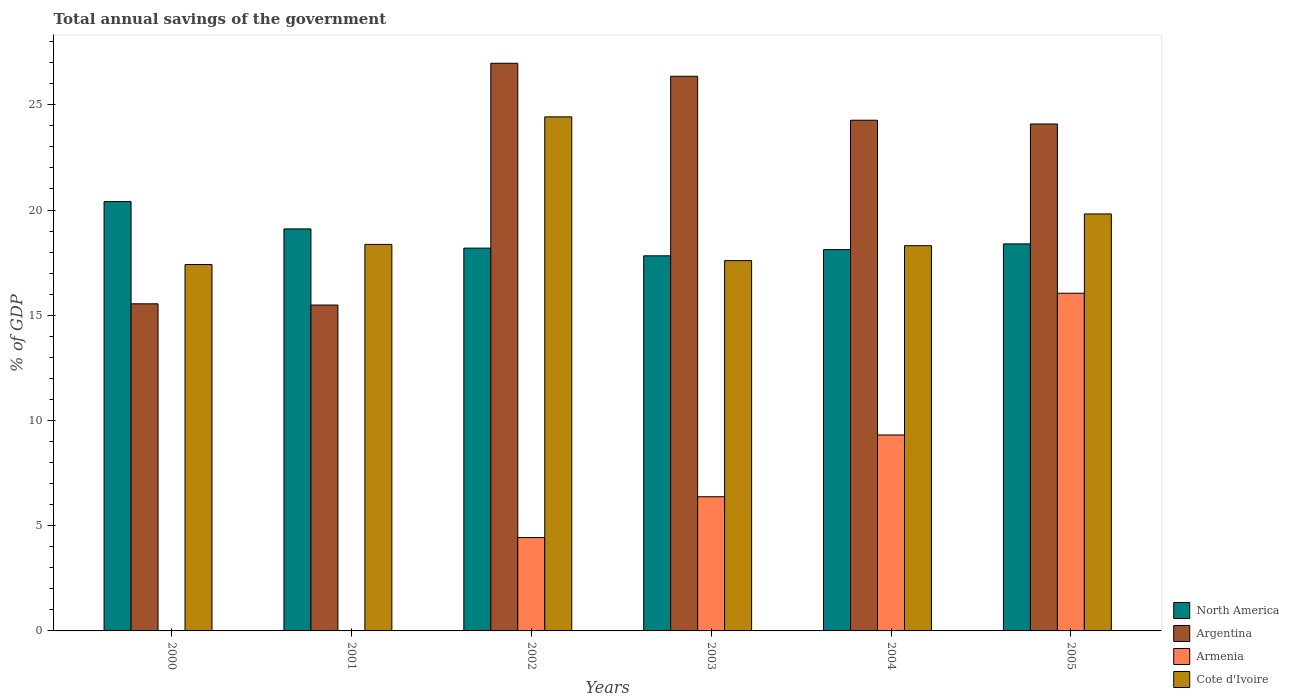How many different coloured bars are there?
Offer a very short reply. 4. How many groups of bars are there?
Provide a short and direct response. 6. Are the number of bars per tick equal to the number of legend labels?
Keep it short and to the point. No. What is the total annual savings of the government in North America in 2005?
Your answer should be compact. 18.39. Across all years, what is the maximum total annual savings of the government in North America?
Ensure brevity in your answer.  20.4. Across all years, what is the minimum total annual savings of the government in North America?
Make the answer very short. 17.82. What is the total total annual savings of the government in Cote d'Ivoire in the graph?
Give a very brief answer. 115.91. What is the difference between the total annual savings of the government in Argentina in 2001 and that in 2004?
Your answer should be compact. -8.78. What is the difference between the total annual savings of the government in Cote d'Ivoire in 2005 and the total annual savings of the government in Armenia in 2004?
Give a very brief answer. 10.5. What is the average total annual savings of the government in Armenia per year?
Provide a short and direct response. 6.03. In the year 2004, what is the difference between the total annual savings of the government in Cote d'Ivoire and total annual savings of the government in Argentina?
Keep it short and to the point. -5.96. What is the ratio of the total annual savings of the government in North America in 2000 to that in 2004?
Your answer should be compact. 1.13. Is the total annual savings of the government in Cote d'Ivoire in 2001 less than that in 2005?
Make the answer very short. Yes. Is the difference between the total annual savings of the government in Cote d'Ivoire in 2002 and 2004 greater than the difference between the total annual savings of the government in Argentina in 2002 and 2004?
Offer a very short reply. Yes. What is the difference between the highest and the second highest total annual savings of the government in Cote d'Ivoire?
Your response must be concise. 4.61. What is the difference between the highest and the lowest total annual savings of the government in Armenia?
Ensure brevity in your answer.  16.05. In how many years, is the total annual savings of the government in Argentina greater than the average total annual savings of the government in Argentina taken over all years?
Your response must be concise. 4. Is the sum of the total annual savings of the government in Armenia in 2002 and 2004 greater than the maximum total annual savings of the government in Argentina across all years?
Offer a very short reply. No. How many bars are there?
Keep it short and to the point. 22. Does the graph contain grids?
Keep it short and to the point. No. Where does the legend appear in the graph?
Ensure brevity in your answer.  Bottom right. What is the title of the graph?
Provide a short and direct response. Total annual savings of the government. Does "Nicaragua" appear as one of the legend labels in the graph?
Offer a terse response. No. What is the label or title of the X-axis?
Provide a succinct answer. Years. What is the label or title of the Y-axis?
Keep it short and to the point. % of GDP. What is the % of GDP in North America in 2000?
Provide a succinct answer. 20.4. What is the % of GDP of Argentina in 2000?
Ensure brevity in your answer.  15.54. What is the % of GDP of Armenia in 2000?
Offer a terse response. 0. What is the % of GDP in Cote d'Ivoire in 2000?
Offer a very short reply. 17.41. What is the % of GDP of North America in 2001?
Offer a very short reply. 19.1. What is the % of GDP of Argentina in 2001?
Provide a short and direct response. 15.49. What is the % of GDP of Armenia in 2001?
Provide a short and direct response. 0. What is the % of GDP in Cote d'Ivoire in 2001?
Your answer should be very brief. 18.37. What is the % of GDP in North America in 2002?
Give a very brief answer. 18.19. What is the % of GDP of Argentina in 2002?
Your answer should be very brief. 26.97. What is the % of GDP in Armenia in 2002?
Provide a short and direct response. 4.44. What is the % of GDP in Cote d'Ivoire in 2002?
Keep it short and to the point. 24.43. What is the % of GDP in North America in 2003?
Give a very brief answer. 17.82. What is the % of GDP in Argentina in 2003?
Provide a short and direct response. 26.35. What is the % of GDP in Armenia in 2003?
Keep it short and to the point. 6.38. What is the % of GDP of Cote d'Ivoire in 2003?
Offer a terse response. 17.59. What is the % of GDP in North America in 2004?
Ensure brevity in your answer.  18.12. What is the % of GDP in Argentina in 2004?
Your response must be concise. 24.27. What is the % of GDP in Armenia in 2004?
Offer a terse response. 9.31. What is the % of GDP in Cote d'Ivoire in 2004?
Offer a terse response. 18.3. What is the % of GDP in North America in 2005?
Provide a succinct answer. 18.39. What is the % of GDP in Argentina in 2005?
Your answer should be very brief. 24.09. What is the % of GDP of Armenia in 2005?
Your response must be concise. 16.05. What is the % of GDP in Cote d'Ivoire in 2005?
Ensure brevity in your answer.  19.81. Across all years, what is the maximum % of GDP in North America?
Make the answer very short. 20.4. Across all years, what is the maximum % of GDP in Argentina?
Provide a succinct answer. 26.97. Across all years, what is the maximum % of GDP in Armenia?
Your answer should be very brief. 16.05. Across all years, what is the maximum % of GDP of Cote d'Ivoire?
Make the answer very short. 24.43. Across all years, what is the minimum % of GDP of North America?
Your response must be concise. 17.82. Across all years, what is the minimum % of GDP of Argentina?
Make the answer very short. 15.49. Across all years, what is the minimum % of GDP of Cote d'Ivoire?
Offer a very short reply. 17.41. What is the total % of GDP in North America in the graph?
Offer a terse response. 112.02. What is the total % of GDP in Argentina in the graph?
Provide a succinct answer. 132.71. What is the total % of GDP in Armenia in the graph?
Make the answer very short. 36.17. What is the total % of GDP in Cote d'Ivoire in the graph?
Your answer should be very brief. 115.91. What is the difference between the % of GDP of North America in 2000 and that in 2001?
Make the answer very short. 1.3. What is the difference between the % of GDP in Argentina in 2000 and that in 2001?
Your response must be concise. 0.06. What is the difference between the % of GDP of Cote d'Ivoire in 2000 and that in 2001?
Provide a succinct answer. -0.96. What is the difference between the % of GDP of North America in 2000 and that in 2002?
Offer a very short reply. 2.21. What is the difference between the % of GDP of Argentina in 2000 and that in 2002?
Offer a very short reply. -11.43. What is the difference between the % of GDP in Cote d'Ivoire in 2000 and that in 2002?
Your answer should be very brief. -7.02. What is the difference between the % of GDP of North America in 2000 and that in 2003?
Your answer should be compact. 2.58. What is the difference between the % of GDP in Argentina in 2000 and that in 2003?
Provide a succinct answer. -10.81. What is the difference between the % of GDP of Cote d'Ivoire in 2000 and that in 2003?
Offer a very short reply. -0.19. What is the difference between the % of GDP of North America in 2000 and that in 2004?
Offer a terse response. 2.28. What is the difference between the % of GDP of Argentina in 2000 and that in 2004?
Your response must be concise. -8.72. What is the difference between the % of GDP of Cote d'Ivoire in 2000 and that in 2004?
Give a very brief answer. -0.9. What is the difference between the % of GDP in North America in 2000 and that in 2005?
Offer a terse response. 2.01. What is the difference between the % of GDP in Argentina in 2000 and that in 2005?
Make the answer very short. -8.55. What is the difference between the % of GDP in Cote d'Ivoire in 2000 and that in 2005?
Provide a short and direct response. -2.4. What is the difference between the % of GDP of North America in 2001 and that in 2002?
Offer a very short reply. 0.91. What is the difference between the % of GDP in Argentina in 2001 and that in 2002?
Offer a terse response. -11.49. What is the difference between the % of GDP in Cote d'Ivoire in 2001 and that in 2002?
Provide a short and direct response. -6.06. What is the difference between the % of GDP in North America in 2001 and that in 2003?
Offer a terse response. 1.28. What is the difference between the % of GDP in Argentina in 2001 and that in 2003?
Give a very brief answer. -10.87. What is the difference between the % of GDP of Cote d'Ivoire in 2001 and that in 2003?
Your answer should be very brief. 0.77. What is the difference between the % of GDP in North America in 2001 and that in 2004?
Ensure brevity in your answer.  0.98. What is the difference between the % of GDP of Argentina in 2001 and that in 2004?
Your response must be concise. -8.78. What is the difference between the % of GDP of Cote d'Ivoire in 2001 and that in 2004?
Your answer should be compact. 0.06. What is the difference between the % of GDP in North America in 2001 and that in 2005?
Offer a very short reply. 0.71. What is the difference between the % of GDP of Argentina in 2001 and that in 2005?
Offer a terse response. -8.6. What is the difference between the % of GDP in Cote d'Ivoire in 2001 and that in 2005?
Give a very brief answer. -1.45. What is the difference between the % of GDP in North America in 2002 and that in 2003?
Provide a short and direct response. 0.36. What is the difference between the % of GDP in Argentina in 2002 and that in 2003?
Your answer should be very brief. 0.62. What is the difference between the % of GDP of Armenia in 2002 and that in 2003?
Your answer should be very brief. -1.94. What is the difference between the % of GDP in Cote d'Ivoire in 2002 and that in 2003?
Your response must be concise. 6.83. What is the difference between the % of GDP of North America in 2002 and that in 2004?
Give a very brief answer. 0.07. What is the difference between the % of GDP in Argentina in 2002 and that in 2004?
Offer a very short reply. 2.71. What is the difference between the % of GDP in Armenia in 2002 and that in 2004?
Offer a very short reply. -4.87. What is the difference between the % of GDP of Cote d'Ivoire in 2002 and that in 2004?
Provide a short and direct response. 6.12. What is the difference between the % of GDP in North America in 2002 and that in 2005?
Provide a short and direct response. -0.2. What is the difference between the % of GDP of Argentina in 2002 and that in 2005?
Offer a terse response. 2.88. What is the difference between the % of GDP of Armenia in 2002 and that in 2005?
Provide a short and direct response. -11.61. What is the difference between the % of GDP of Cote d'Ivoire in 2002 and that in 2005?
Your answer should be compact. 4.61. What is the difference between the % of GDP in North America in 2003 and that in 2004?
Offer a very short reply. -0.3. What is the difference between the % of GDP in Argentina in 2003 and that in 2004?
Provide a succinct answer. 2.09. What is the difference between the % of GDP of Armenia in 2003 and that in 2004?
Your answer should be very brief. -2.94. What is the difference between the % of GDP of Cote d'Ivoire in 2003 and that in 2004?
Ensure brevity in your answer.  -0.71. What is the difference between the % of GDP in North America in 2003 and that in 2005?
Offer a very short reply. -0.57. What is the difference between the % of GDP of Argentina in 2003 and that in 2005?
Your answer should be compact. 2.27. What is the difference between the % of GDP of Armenia in 2003 and that in 2005?
Keep it short and to the point. -9.67. What is the difference between the % of GDP of Cote d'Ivoire in 2003 and that in 2005?
Your response must be concise. -2.22. What is the difference between the % of GDP in North America in 2004 and that in 2005?
Keep it short and to the point. -0.27. What is the difference between the % of GDP in Argentina in 2004 and that in 2005?
Your response must be concise. 0.18. What is the difference between the % of GDP in Armenia in 2004 and that in 2005?
Your response must be concise. -6.74. What is the difference between the % of GDP of Cote d'Ivoire in 2004 and that in 2005?
Ensure brevity in your answer.  -1.51. What is the difference between the % of GDP in North America in 2000 and the % of GDP in Argentina in 2001?
Your response must be concise. 4.92. What is the difference between the % of GDP of North America in 2000 and the % of GDP of Cote d'Ivoire in 2001?
Ensure brevity in your answer.  2.04. What is the difference between the % of GDP of Argentina in 2000 and the % of GDP of Cote d'Ivoire in 2001?
Offer a very short reply. -2.82. What is the difference between the % of GDP in North America in 2000 and the % of GDP in Argentina in 2002?
Your answer should be compact. -6.57. What is the difference between the % of GDP of North America in 2000 and the % of GDP of Armenia in 2002?
Your answer should be compact. 15.96. What is the difference between the % of GDP of North America in 2000 and the % of GDP of Cote d'Ivoire in 2002?
Provide a succinct answer. -4.02. What is the difference between the % of GDP in Argentina in 2000 and the % of GDP in Armenia in 2002?
Provide a short and direct response. 11.11. What is the difference between the % of GDP of Argentina in 2000 and the % of GDP of Cote d'Ivoire in 2002?
Your answer should be very brief. -8.88. What is the difference between the % of GDP of North America in 2000 and the % of GDP of Argentina in 2003?
Ensure brevity in your answer.  -5.95. What is the difference between the % of GDP of North America in 2000 and the % of GDP of Armenia in 2003?
Offer a very short reply. 14.03. What is the difference between the % of GDP of North America in 2000 and the % of GDP of Cote d'Ivoire in 2003?
Make the answer very short. 2.81. What is the difference between the % of GDP of Argentina in 2000 and the % of GDP of Armenia in 2003?
Your response must be concise. 9.17. What is the difference between the % of GDP of Argentina in 2000 and the % of GDP of Cote d'Ivoire in 2003?
Ensure brevity in your answer.  -2.05. What is the difference between the % of GDP in North America in 2000 and the % of GDP in Argentina in 2004?
Your response must be concise. -3.87. What is the difference between the % of GDP in North America in 2000 and the % of GDP in Armenia in 2004?
Ensure brevity in your answer.  11.09. What is the difference between the % of GDP in North America in 2000 and the % of GDP in Cote d'Ivoire in 2004?
Your response must be concise. 2.1. What is the difference between the % of GDP in Argentina in 2000 and the % of GDP in Armenia in 2004?
Your answer should be compact. 6.23. What is the difference between the % of GDP in Argentina in 2000 and the % of GDP in Cote d'Ivoire in 2004?
Offer a terse response. -2.76. What is the difference between the % of GDP of North America in 2000 and the % of GDP of Argentina in 2005?
Keep it short and to the point. -3.69. What is the difference between the % of GDP in North America in 2000 and the % of GDP in Armenia in 2005?
Offer a terse response. 4.36. What is the difference between the % of GDP of North America in 2000 and the % of GDP of Cote d'Ivoire in 2005?
Offer a terse response. 0.59. What is the difference between the % of GDP in Argentina in 2000 and the % of GDP in Armenia in 2005?
Your answer should be very brief. -0.5. What is the difference between the % of GDP of Argentina in 2000 and the % of GDP of Cote d'Ivoire in 2005?
Keep it short and to the point. -4.27. What is the difference between the % of GDP in North America in 2001 and the % of GDP in Argentina in 2002?
Your answer should be compact. -7.87. What is the difference between the % of GDP in North America in 2001 and the % of GDP in Armenia in 2002?
Your answer should be compact. 14.66. What is the difference between the % of GDP of North America in 2001 and the % of GDP of Cote d'Ivoire in 2002?
Your answer should be compact. -5.32. What is the difference between the % of GDP in Argentina in 2001 and the % of GDP in Armenia in 2002?
Your answer should be very brief. 11.05. What is the difference between the % of GDP in Argentina in 2001 and the % of GDP in Cote d'Ivoire in 2002?
Your response must be concise. -8.94. What is the difference between the % of GDP of North America in 2001 and the % of GDP of Argentina in 2003?
Provide a succinct answer. -7.25. What is the difference between the % of GDP in North America in 2001 and the % of GDP in Armenia in 2003?
Your answer should be compact. 12.73. What is the difference between the % of GDP in North America in 2001 and the % of GDP in Cote d'Ivoire in 2003?
Make the answer very short. 1.51. What is the difference between the % of GDP of Argentina in 2001 and the % of GDP of Armenia in 2003?
Your response must be concise. 9.11. What is the difference between the % of GDP in Argentina in 2001 and the % of GDP in Cote d'Ivoire in 2003?
Offer a very short reply. -2.11. What is the difference between the % of GDP in North America in 2001 and the % of GDP in Argentina in 2004?
Offer a very short reply. -5.16. What is the difference between the % of GDP of North America in 2001 and the % of GDP of Armenia in 2004?
Ensure brevity in your answer.  9.79. What is the difference between the % of GDP in North America in 2001 and the % of GDP in Cote d'Ivoire in 2004?
Your response must be concise. 0.8. What is the difference between the % of GDP in Argentina in 2001 and the % of GDP in Armenia in 2004?
Your response must be concise. 6.17. What is the difference between the % of GDP of Argentina in 2001 and the % of GDP of Cote d'Ivoire in 2004?
Your answer should be compact. -2.82. What is the difference between the % of GDP of North America in 2001 and the % of GDP of Argentina in 2005?
Keep it short and to the point. -4.99. What is the difference between the % of GDP in North America in 2001 and the % of GDP in Armenia in 2005?
Provide a short and direct response. 3.06. What is the difference between the % of GDP in North America in 2001 and the % of GDP in Cote d'Ivoire in 2005?
Ensure brevity in your answer.  -0.71. What is the difference between the % of GDP of Argentina in 2001 and the % of GDP of Armenia in 2005?
Your answer should be compact. -0.56. What is the difference between the % of GDP in Argentina in 2001 and the % of GDP in Cote d'Ivoire in 2005?
Provide a succinct answer. -4.33. What is the difference between the % of GDP in North America in 2002 and the % of GDP in Argentina in 2003?
Provide a short and direct response. -8.17. What is the difference between the % of GDP in North America in 2002 and the % of GDP in Armenia in 2003?
Your answer should be very brief. 11.81. What is the difference between the % of GDP in North America in 2002 and the % of GDP in Cote d'Ivoire in 2003?
Your answer should be compact. 0.59. What is the difference between the % of GDP of Argentina in 2002 and the % of GDP of Armenia in 2003?
Offer a very short reply. 20.6. What is the difference between the % of GDP in Argentina in 2002 and the % of GDP in Cote d'Ivoire in 2003?
Your answer should be compact. 9.38. What is the difference between the % of GDP of Armenia in 2002 and the % of GDP of Cote d'Ivoire in 2003?
Make the answer very short. -13.16. What is the difference between the % of GDP of North America in 2002 and the % of GDP of Argentina in 2004?
Your answer should be compact. -6.08. What is the difference between the % of GDP in North America in 2002 and the % of GDP in Armenia in 2004?
Your response must be concise. 8.88. What is the difference between the % of GDP in North America in 2002 and the % of GDP in Cote d'Ivoire in 2004?
Your answer should be compact. -0.12. What is the difference between the % of GDP in Argentina in 2002 and the % of GDP in Armenia in 2004?
Provide a short and direct response. 17.66. What is the difference between the % of GDP in Argentina in 2002 and the % of GDP in Cote d'Ivoire in 2004?
Provide a short and direct response. 8.67. What is the difference between the % of GDP of Armenia in 2002 and the % of GDP of Cote d'Ivoire in 2004?
Provide a short and direct response. -13.87. What is the difference between the % of GDP in North America in 2002 and the % of GDP in Argentina in 2005?
Give a very brief answer. -5.9. What is the difference between the % of GDP of North America in 2002 and the % of GDP of Armenia in 2005?
Your response must be concise. 2.14. What is the difference between the % of GDP in North America in 2002 and the % of GDP in Cote d'Ivoire in 2005?
Ensure brevity in your answer.  -1.62. What is the difference between the % of GDP of Argentina in 2002 and the % of GDP of Armenia in 2005?
Make the answer very short. 10.93. What is the difference between the % of GDP of Argentina in 2002 and the % of GDP of Cote d'Ivoire in 2005?
Ensure brevity in your answer.  7.16. What is the difference between the % of GDP in Armenia in 2002 and the % of GDP in Cote d'Ivoire in 2005?
Offer a terse response. -15.38. What is the difference between the % of GDP in North America in 2003 and the % of GDP in Argentina in 2004?
Your answer should be compact. -6.44. What is the difference between the % of GDP in North America in 2003 and the % of GDP in Armenia in 2004?
Offer a terse response. 8.51. What is the difference between the % of GDP in North America in 2003 and the % of GDP in Cote d'Ivoire in 2004?
Ensure brevity in your answer.  -0.48. What is the difference between the % of GDP of Argentina in 2003 and the % of GDP of Armenia in 2004?
Give a very brief answer. 17.04. What is the difference between the % of GDP of Argentina in 2003 and the % of GDP of Cote d'Ivoire in 2004?
Offer a very short reply. 8.05. What is the difference between the % of GDP in Armenia in 2003 and the % of GDP in Cote d'Ivoire in 2004?
Your answer should be compact. -11.93. What is the difference between the % of GDP of North America in 2003 and the % of GDP of Argentina in 2005?
Keep it short and to the point. -6.26. What is the difference between the % of GDP of North America in 2003 and the % of GDP of Armenia in 2005?
Your answer should be very brief. 1.78. What is the difference between the % of GDP in North America in 2003 and the % of GDP in Cote d'Ivoire in 2005?
Your response must be concise. -1.99. What is the difference between the % of GDP in Argentina in 2003 and the % of GDP in Armenia in 2005?
Make the answer very short. 10.31. What is the difference between the % of GDP of Argentina in 2003 and the % of GDP of Cote d'Ivoire in 2005?
Your response must be concise. 6.54. What is the difference between the % of GDP of Armenia in 2003 and the % of GDP of Cote d'Ivoire in 2005?
Give a very brief answer. -13.44. What is the difference between the % of GDP in North America in 2004 and the % of GDP in Argentina in 2005?
Offer a terse response. -5.97. What is the difference between the % of GDP of North America in 2004 and the % of GDP of Armenia in 2005?
Provide a short and direct response. 2.07. What is the difference between the % of GDP in North America in 2004 and the % of GDP in Cote d'Ivoire in 2005?
Offer a very short reply. -1.69. What is the difference between the % of GDP in Argentina in 2004 and the % of GDP in Armenia in 2005?
Your answer should be compact. 8.22. What is the difference between the % of GDP of Argentina in 2004 and the % of GDP of Cote d'Ivoire in 2005?
Provide a succinct answer. 4.45. What is the difference between the % of GDP of Armenia in 2004 and the % of GDP of Cote d'Ivoire in 2005?
Make the answer very short. -10.5. What is the average % of GDP of North America per year?
Provide a short and direct response. 18.67. What is the average % of GDP of Argentina per year?
Ensure brevity in your answer.  22.12. What is the average % of GDP in Armenia per year?
Make the answer very short. 6.03. What is the average % of GDP of Cote d'Ivoire per year?
Your answer should be compact. 19.32. In the year 2000, what is the difference between the % of GDP in North America and % of GDP in Argentina?
Your answer should be very brief. 4.86. In the year 2000, what is the difference between the % of GDP in North America and % of GDP in Cote d'Ivoire?
Ensure brevity in your answer.  2.99. In the year 2000, what is the difference between the % of GDP in Argentina and % of GDP in Cote d'Ivoire?
Give a very brief answer. -1.87. In the year 2001, what is the difference between the % of GDP in North America and % of GDP in Argentina?
Keep it short and to the point. 3.62. In the year 2001, what is the difference between the % of GDP in North America and % of GDP in Cote d'Ivoire?
Give a very brief answer. 0.74. In the year 2001, what is the difference between the % of GDP of Argentina and % of GDP of Cote d'Ivoire?
Your answer should be very brief. -2.88. In the year 2002, what is the difference between the % of GDP of North America and % of GDP of Argentina?
Give a very brief answer. -8.78. In the year 2002, what is the difference between the % of GDP in North America and % of GDP in Armenia?
Provide a succinct answer. 13.75. In the year 2002, what is the difference between the % of GDP in North America and % of GDP in Cote d'Ivoire?
Keep it short and to the point. -6.24. In the year 2002, what is the difference between the % of GDP of Argentina and % of GDP of Armenia?
Ensure brevity in your answer.  22.54. In the year 2002, what is the difference between the % of GDP in Argentina and % of GDP in Cote d'Ivoire?
Offer a very short reply. 2.55. In the year 2002, what is the difference between the % of GDP in Armenia and % of GDP in Cote d'Ivoire?
Make the answer very short. -19.99. In the year 2003, what is the difference between the % of GDP of North America and % of GDP of Argentina?
Provide a short and direct response. -8.53. In the year 2003, what is the difference between the % of GDP of North America and % of GDP of Armenia?
Offer a terse response. 11.45. In the year 2003, what is the difference between the % of GDP in North America and % of GDP in Cote d'Ivoire?
Keep it short and to the point. 0.23. In the year 2003, what is the difference between the % of GDP of Argentina and % of GDP of Armenia?
Your answer should be very brief. 19.98. In the year 2003, what is the difference between the % of GDP of Argentina and % of GDP of Cote d'Ivoire?
Your response must be concise. 8.76. In the year 2003, what is the difference between the % of GDP of Armenia and % of GDP of Cote d'Ivoire?
Give a very brief answer. -11.22. In the year 2004, what is the difference between the % of GDP of North America and % of GDP of Argentina?
Offer a very short reply. -6.15. In the year 2004, what is the difference between the % of GDP in North America and % of GDP in Armenia?
Provide a succinct answer. 8.81. In the year 2004, what is the difference between the % of GDP of North America and % of GDP of Cote d'Ivoire?
Offer a terse response. -0.19. In the year 2004, what is the difference between the % of GDP in Argentina and % of GDP in Armenia?
Give a very brief answer. 14.96. In the year 2004, what is the difference between the % of GDP of Argentina and % of GDP of Cote d'Ivoire?
Offer a very short reply. 5.96. In the year 2004, what is the difference between the % of GDP in Armenia and % of GDP in Cote d'Ivoire?
Ensure brevity in your answer.  -8.99. In the year 2005, what is the difference between the % of GDP in North America and % of GDP in Argentina?
Offer a very short reply. -5.7. In the year 2005, what is the difference between the % of GDP of North America and % of GDP of Armenia?
Ensure brevity in your answer.  2.34. In the year 2005, what is the difference between the % of GDP of North America and % of GDP of Cote d'Ivoire?
Provide a short and direct response. -1.42. In the year 2005, what is the difference between the % of GDP of Argentina and % of GDP of Armenia?
Offer a very short reply. 8.04. In the year 2005, what is the difference between the % of GDP in Argentina and % of GDP in Cote d'Ivoire?
Offer a terse response. 4.28. In the year 2005, what is the difference between the % of GDP in Armenia and % of GDP in Cote d'Ivoire?
Your answer should be very brief. -3.77. What is the ratio of the % of GDP in North America in 2000 to that in 2001?
Ensure brevity in your answer.  1.07. What is the ratio of the % of GDP of Argentina in 2000 to that in 2001?
Provide a short and direct response. 1. What is the ratio of the % of GDP in Cote d'Ivoire in 2000 to that in 2001?
Provide a succinct answer. 0.95. What is the ratio of the % of GDP in North America in 2000 to that in 2002?
Your answer should be very brief. 1.12. What is the ratio of the % of GDP in Argentina in 2000 to that in 2002?
Offer a terse response. 0.58. What is the ratio of the % of GDP in Cote d'Ivoire in 2000 to that in 2002?
Provide a succinct answer. 0.71. What is the ratio of the % of GDP in North America in 2000 to that in 2003?
Provide a succinct answer. 1.14. What is the ratio of the % of GDP of Argentina in 2000 to that in 2003?
Your response must be concise. 0.59. What is the ratio of the % of GDP in Cote d'Ivoire in 2000 to that in 2003?
Offer a terse response. 0.99. What is the ratio of the % of GDP in North America in 2000 to that in 2004?
Your response must be concise. 1.13. What is the ratio of the % of GDP of Argentina in 2000 to that in 2004?
Provide a short and direct response. 0.64. What is the ratio of the % of GDP of Cote d'Ivoire in 2000 to that in 2004?
Make the answer very short. 0.95. What is the ratio of the % of GDP in North America in 2000 to that in 2005?
Your response must be concise. 1.11. What is the ratio of the % of GDP in Argentina in 2000 to that in 2005?
Make the answer very short. 0.65. What is the ratio of the % of GDP in Cote d'Ivoire in 2000 to that in 2005?
Provide a short and direct response. 0.88. What is the ratio of the % of GDP of North America in 2001 to that in 2002?
Your answer should be very brief. 1.05. What is the ratio of the % of GDP in Argentina in 2001 to that in 2002?
Ensure brevity in your answer.  0.57. What is the ratio of the % of GDP in Cote d'Ivoire in 2001 to that in 2002?
Give a very brief answer. 0.75. What is the ratio of the % of GDP in North America in 2001 to that in 2003?
Offer a very short reply. 1.07. What is the ratio of the % of GDP of Argentina in 2001 to that in 2003?
Give a very brief answer. 0.59. What is the ratio of the % of GDP in Cote d'Ivoire in 2001 to that in 2003?
Offer a very short reply. 1.04. What is the ratio of the % of GDP in North America in 2001 to that in 2004?
Offer a very short reply. 1.05. What is the ratio of the % of GDP of Argentina in 2001 to that in 2004?
Provide a succinct answer. 0.64. What is the ratio of the % of GDP in North America in 2001 to that in 2005?
Keep it short and to the point. 1.04. What is the ratio of the % of GDP of Argentina in 2001 to that in 2005?
Offer a very short reply. 0.64. What is the ratio of the % of GDP in Cote d'Ivoire in 2001 to that in 2005?
Provide a succinct answer. 0.93. What is the ratio of the % of GDP of North America in 2002 to that in 2003?
Your answer should be compact. 1.02. What is the ratio of the % of GDP of Argentina in 2002 to that in 2003?
Your answer should be compact. 1.02. What is the ratio of the % of GDP of Armenia in 2002 to that in 2003?
Your answer should be very brief. 0.7. What is the ratio of the % of GDP in Cote d'Ivoire in 2002 to that in 2003?
Keep it short and to the point. 1.39. What is the ratio of the % of GDP in Argentina in 2002 to that in 2004?
Make the answer very short. 1.11. What is the ratio of the % of GDP in Armenia in 2002 to that in 2004?
Keep it short and to the point. 0.48. What is the ratio of the % of GDP of Cote d'Ivoire in 2002 to that in 2004?
Offer a terse response. 1.33. What is the ratio of the % of GDP of North America in 2002 to that in 2005?
Your answer should be compact. 0.99. What is the ratio of the % of GDP in Argentina in 2002 to that in 2005?
Make the answer very short. 1.12. What is the ratio of the % of GDP in Armenia in 2002 to that in 2005?
Ensure brevity in your answer.  0.28. What is the ratio of the % of GDP in Cote d'Ivoire in 2002 to that in 2005?
Your answer should be compact. 1.23. What is the ratio of the % of GDP of North America in 2003 to that in 2004?
Ensure brevity in your answer.  0.98. What is the ratio of the % of GDP in Argentina in 2003 to that in 2004?
Provide a short and direct response. 1.09. What is the ratio of the % of GDP in Armenia in 2003 to that in 2004?
Your response must be concise. 0.68. What is the ratio of the % of GDP of Cote d'Ivoire in 2003 to that in 2004?
Make the answer very short. 0.96. What is the ratio of the % of GDP of North America in 2003 to that in 2005?
Offer a terse response. 0.97. What is the ratio of the % of GDP in Argentina in 2003 to that in 2005?
Provide a succinct answer. 1.09. What is the ratio of the % of GDP of Armenia in 2003 to that in 2005?
Offer a very short reply. 0.4. What is the ratio of the % of GDP in Cote d'Ivoire in 2003 to that in 2005?
Offer a very short reply. 0.89. What is the ratio of the % of GDP of Argentina in 2004 to that in 2005?
Keep it short and to the point. 1.01. What is the ratio of the % of GDP in Armenia in 2004 to that in 2005?
Provide a succinct answer. 0.58. What is the ratio of the % of GDP in Cote d'Ivoire in 2004 to that in 2005?
Keep it short and to the point. 0.92. What is the difference between the highest and the second highest % of GDP in North America?
Make the answer very short. 1.3. What is the difference between the highest and the second highest % of GDP of Argentina?
Offer a terse response. 0.62. What is the difference between the highest and the second highest % of GDP in Armenia?
Offer a very short reply. 6.74. What is the difference between the highest and the second highest % of GDP of Cote d'Ivoire?
Your response must be concise. 4.61. What is the difference between the highest and the lowest % of GDP of North America?
Your answer should be compact. 2.58. What is the difference between the highest and the lowest % of GDP in Argentina?
Offer a very short reply. 11.49. What is the difference between the highest and the lowest % of GDP in Armenia?
Your answer should be compact. 16.05. What is the difference between the highest and the lowest % of GDP of Cote d'Ivoire?
Provide a succinct answer. 7.02. 